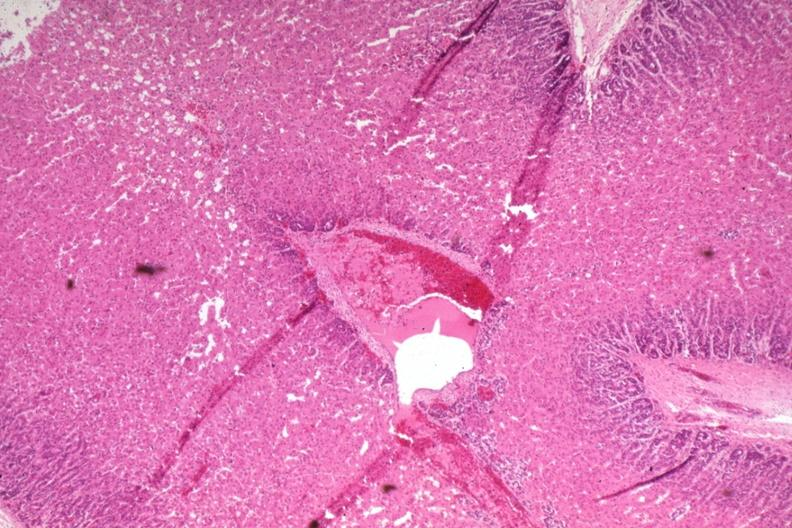what is present?
Answer the question using a single word or phrase. Normal newborn 